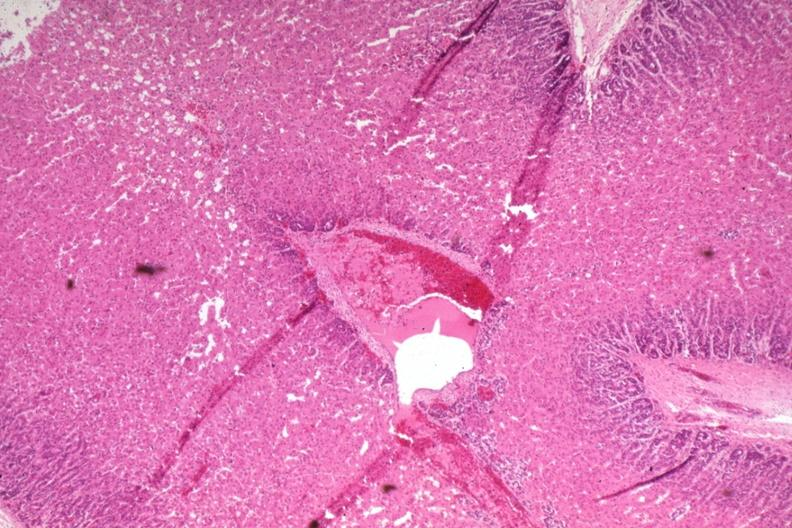what is present?
Answer the question using a single word or phrase. Normal newborn 